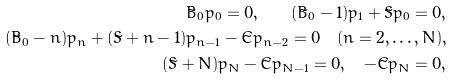<formula> <loc_0><loc_0><loc_500><loc_500>\tilde { B } _ { 0 } p _ { 0 } = 0 , \quad ( \tilde { B } _ { 0 } - 1 ) p _ { 1 } + \tilde { S } p _ { 0 } = 0 , \\ ( \tilde { B } _ { 0 } - n ) p _ { n } + ( \tilde { S } + n - 1 ) p _ { n - 1 } - \tilde { C } p _ { n - 2 } = 0 \quad ( n = 2 , \dots , N ) , \\ ( \tilde { S } + N ) p _ { N } - \tilde { C } p _ { N - 1 } = 0 , \quad - \tilde { C } p _ { N } = 0 ,</formula> 